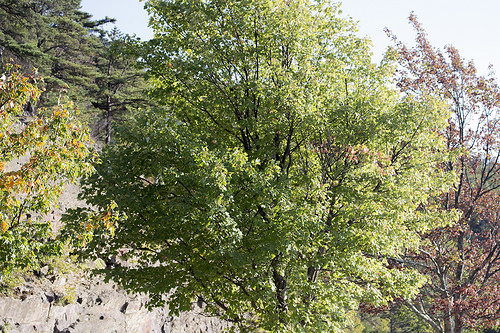<image>
Is the tree behind the mountain? No. The tree is not behind the mountain. From this viewpoint, the tree appears to be positioned elsewhere in the scene. Where is the tree in relation to the cliff? Is it above the cliff? No. The tree is not positioned above the cliff. The vertical arrangement shows a different relationship. 